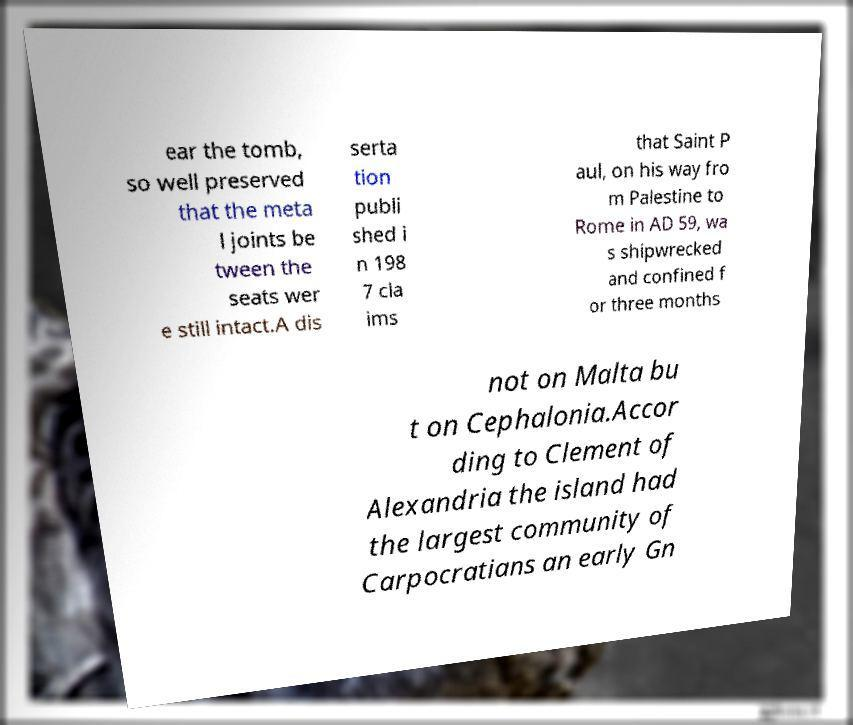Could you assist in decoding the text presented in this image and type it out clearly? ear the tomb, so well preserved that the meta l joints be tween the seats wer e still intact.A dis serta tion publi shed i n 198 7 cla ims that Saint P aul, on his way fro m Palestine to Rome in AD 59, wa s shipwrecked and confined f or three months not on Malta bu t on Cephalonia.Accor ding to Clement of Alexandria the island had the largest community of Carpocratians an early Gn 